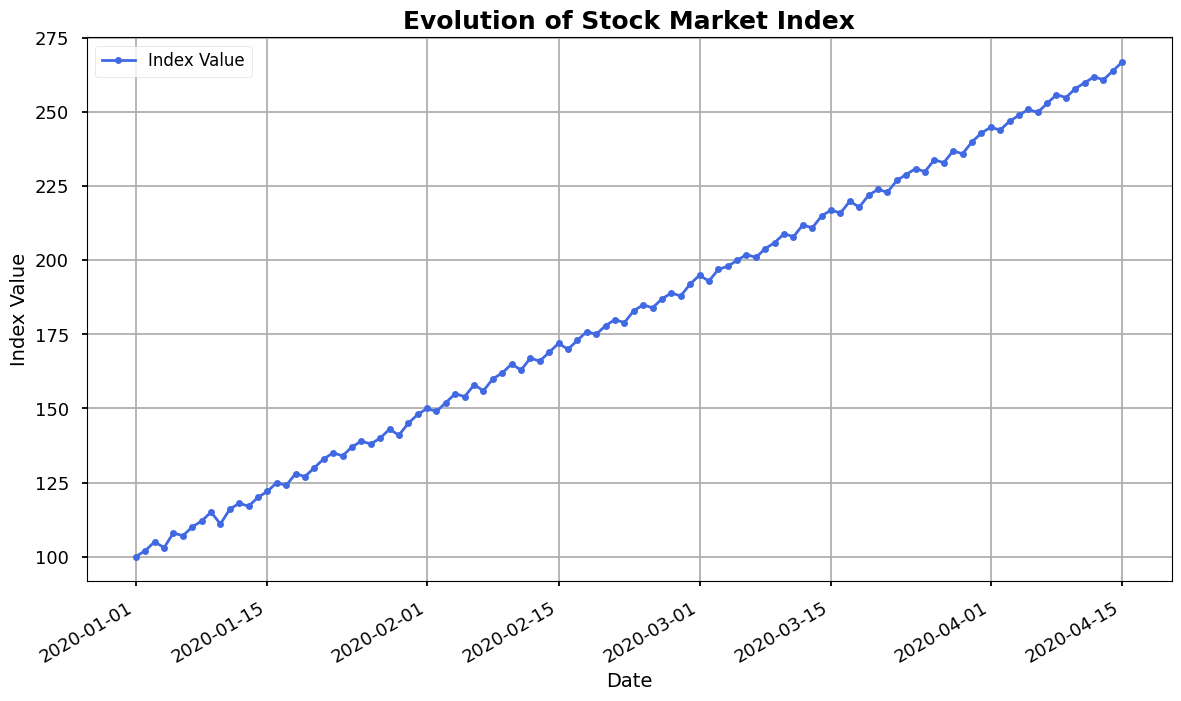What is the overall trend of the stock market index from January 1, 2020, to April 15, 2020? The overall trend can be determined by observing the line's general direction in the plot. The index increases steadily from January 1, 2020, to April 15, 2020.
Answer: Upward trend Which date shows the highest index value on the plot? By inspecting the highest point on the plot, you can identify the peak value of the index and find the corresponding date.
Answer: April 15, 2020 What is the approximate index value on February 1, 2020? Locate the date February 1, 2020, along the x-axis and observe the corresponding index value on the y-axis.
Answer: 150 How does the index value on March 1, 2020, compare to that on February 1, 2020? Compare the index values at the points corresponding to March 1, 2020, and February 1, 2020. March 1 has a higher index value.
Answer: Higher on March 1, 2020 What is the difference between the index values on January 1, 2020, and January 31, 2020? Locate the index values for January 1 (100) and January 31 (148) and subtract the January 1 value from the January 31 value.
Answer: 48 On which date does the plot show the first significant drop in the index value? Identify the first noticeable decrease in the line graph; this occurs after January 3, 2020, when the index drops from 105 to 103.
Answer: January 4, 2020 Calculate the average index value for the first week of January 2020. Sum the index values from January 1 to January 7 (100 + 102 + 105 + 103 + 108 + 107 + 110) and divide by the number of days (7). The average is 735 / 7.
Answer: 105 Compare the overall index trend in February 2020 with March 2020. Analyze the slope of the index lines in February and March. The index steadily increases in both months, but the trend appears slightly more aggressive in March.
Answer: Both are upward Which two consecutive days have the highest increase in index value? Compare the differences in index values for all consecutive days; the largest increase is between April 9, 2020 (255) and April 10, 2020 (258).
Answer: April 9-10, 2020 Does the index show more fluctuations at the beginning or the end of the timeline? Observe the variability of the line graph. It exhibits more fluctuations towards the end of the timeline.
Answer: End of the timeline 